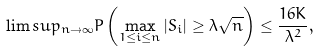<formula> <loc_0><loc_0><loc_500><loc_500>\lim s u p _ { n \to \infty } P \left ( \max _ { 1 \leq i \leq n } | S _ { i } | \geq \lambda \sqrt { n } \right ) \leq \frac { 1 6 K } { \lambda ^ { 2 } } ,</formula> 